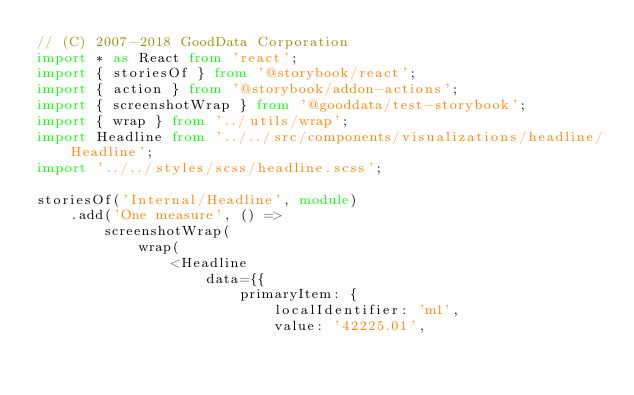<code> <loc_0><loc_0><loc_500><loc_500><_TypeScript_>// (C) 2007-2018 GoodData Corporation
import * as React from 'react';
import { storiesOf } from '@storybook/react';
import { action } from '@storybook/addon-actions';
import { screenshotWrap } from '@gooddata/test-storybook';
import { wrap } from '../utils/wrap';
import Headline from '../../src/components/visualizations/headline/Headline';
import '../../styles/scss/headline.scss';

storiesOf('Internal/Headline', module)
    .add('One measure', () =>
        screenshotWrap(
            wrap(
                <Headline
                    data={{
                        primaryItem: {
                            localIdentifier: 'm1',
                            value: '42225.01',</code> 